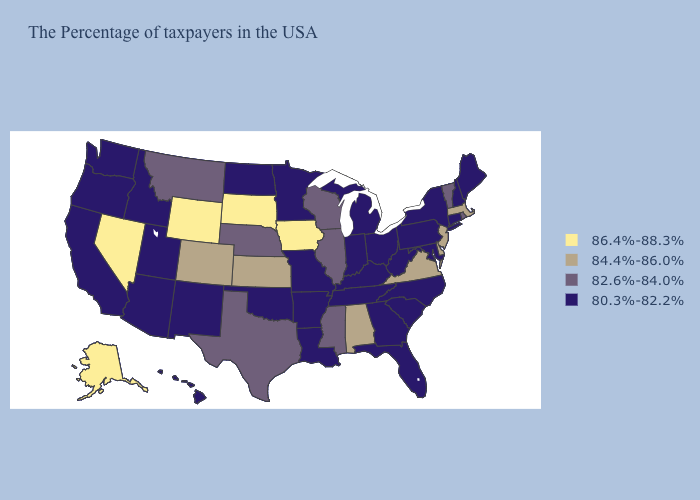What is the highest value in the MidWest ?
Give a very brief answer. 86.4%-88.3%. What is the value of Texas?
Answer briefly. 82.6%-84.0%. What is the value of Nebraska?
Short answer required. 82.6%-84.0%. What is the highest value in states that border Louisiana?
Keep it brief. 82.6%-84.0%. What is the value of California?
Give a very brief answer. 80.3%-82.2%. Is the legend a continuous bar?
Concise answer only. No. Does Maine have the lowest value in the USA?
Give a very brief answer. Yes. Does Ohio have a higher value than Michigan?
Give a very brief answer. No. What is the value of Virginia?
Short answer required. 84.4%-86.0%. Which states have the lowest value in the Northeast?
Concise answer only. Maine, New Hampshire, Connecticut, New York, Pennsylvania. What is the highest value in the Northeast ?
Short answer required. 84.4%-86.0%. What is the highest value in the South ?
Keep it brief. 84.4%-86.0%. Name the states that have a value in the range 84.4%-86.0%?
Answer briefly. Massachusetts, New Jersey, Delaware, Virginia, Alabama, Kansas, Colorado. Does Alaska have the highest value in the USA?
Quick response, please. Yes. Among the states that border Michigan , which have the highest value?
Be succinct. Wisconsin. 